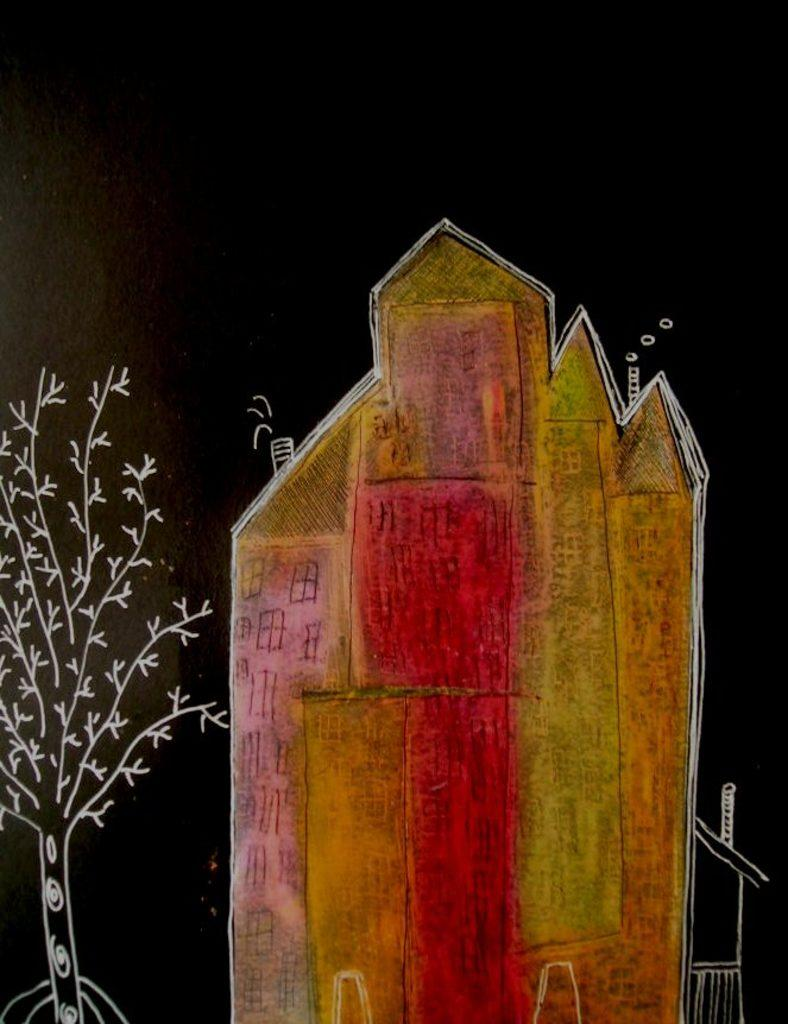What type of artwork is present in the image? The image contains a sketch. What is depicted in the sketch? The sketch includes a picture of a house and a tree. How many toys are visible in the image? There are no toys present in the image; it contains a sketch of a house and a tree. What type of tool is being used to rake leaves in the image? There is no tool or activity related to raking leaves in the image; it contains a sketch of a house and a tree. 